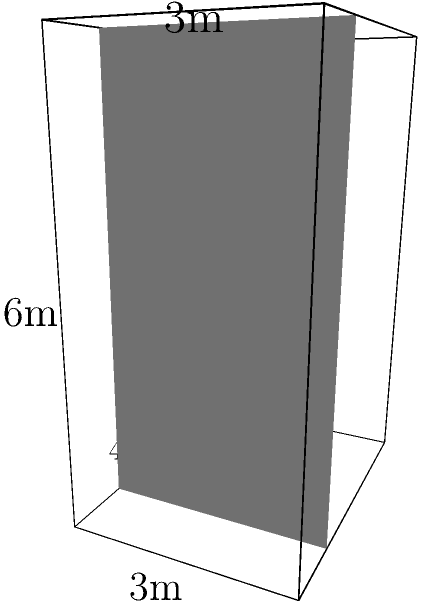As part of your new reality TV show's dressing room, you're designing a unique mirror installation. The installation consists of a rectangular prism with a triangular prism attached to one side, as shown in the diagram. The rectangular prism measures 4m x 3m x 6m, while the triangular prism has a base of 3m x 3m and extends the full 6m length of the rectangular prism. Calculate the total surface area of the mirror installation, excluding the bottom face and the face where the triangular prism is attached to the rectangular prism. Let's break this down step-by-step:

1) For the rectangular prism:
   - Front and back faces: $2 * (4m * 6m) = 48m^2$
   - Top face: $1 * (4m * 3m) = 12m^2$
   - One side face: $1 * (3m * 6m) = 18m^2$
   
2) For the triangular prism:
   - Two triangular faces: $2 * (1/2 * 3m * 3m) = 9m^2$
   - Two rectangular faces: $2 * (3m * 6m) = 36m^2$
   
3) Total surface area:
   $$ 48m^2 + 12m^2 + 18m^2 + 9m^2 + 36m^2 = 123m^2 $$

Note that we excluded the bottom face of the rectangular prism and the face where the triangular prism is attached to the rectangular prism, as specified in the question.
Answer: $123m^2$ 